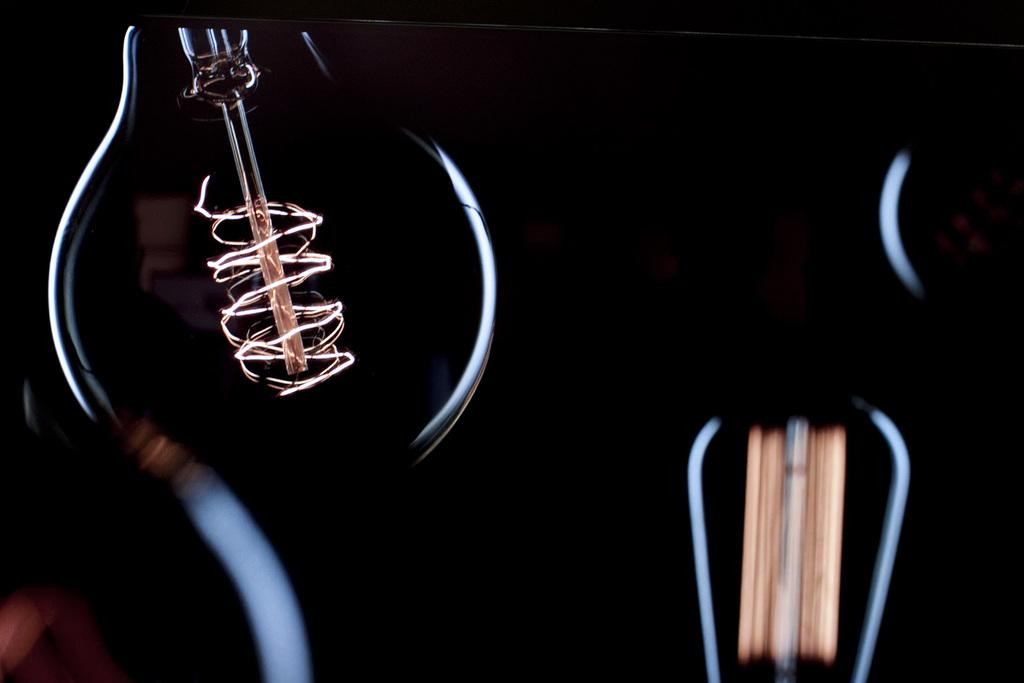What is the main object in the image? There is a bulb in the image. How would you describe the overall lighting in the image? The image appears to be mostly dark. Can you describe any specific features of the bulb? The bulb has a filament. Is there any indication that the image has been altered or edited? The image may have been edited. What type of waste can be seen in the image? There is no waste present in the image; it features a bulb with a filament. Can you describe the magic performed by the carpenter in the image? There is no carpenter or magic present in the image; it only shows a bulb with a filament. 